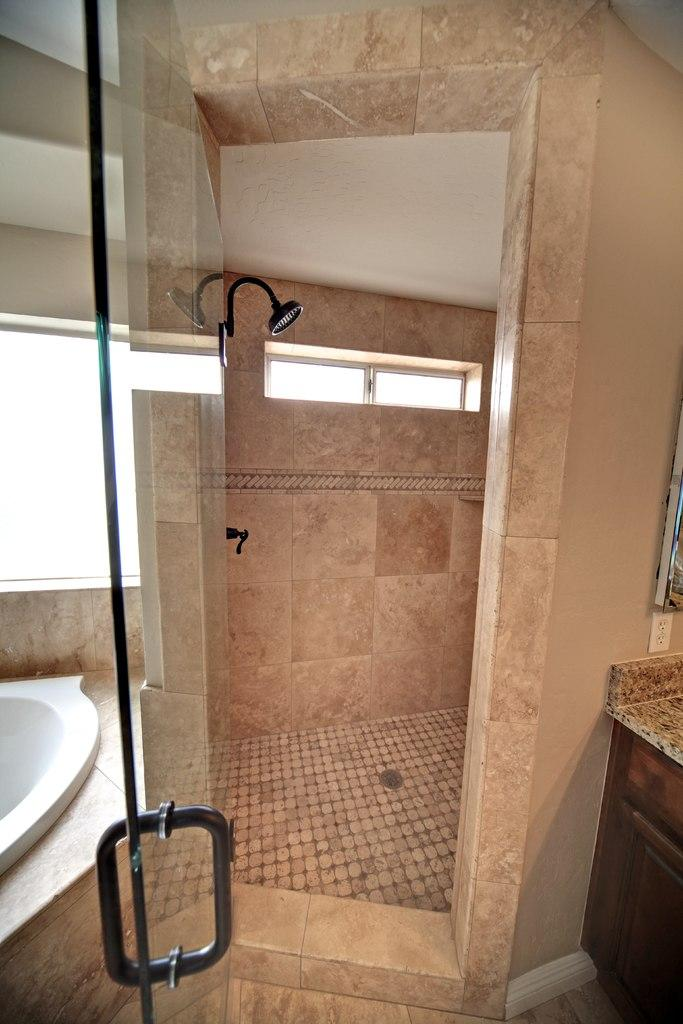What type of door is visible in the image? There is a glass door in the image. What type of furniture is present in the image? There is a cabinet in the image. What is the primary purpose of the room in the image? The presence of a bathtub, shower, and glass door suggests that the room is likely a bathroom. What is the background of the image made of? There is a wall in the image. What type of banana is hanging from the ceiling in the image? There is no banana present in the image. What type of skirt is draped over the bathtub in the image? There is no skirt present in the image. 